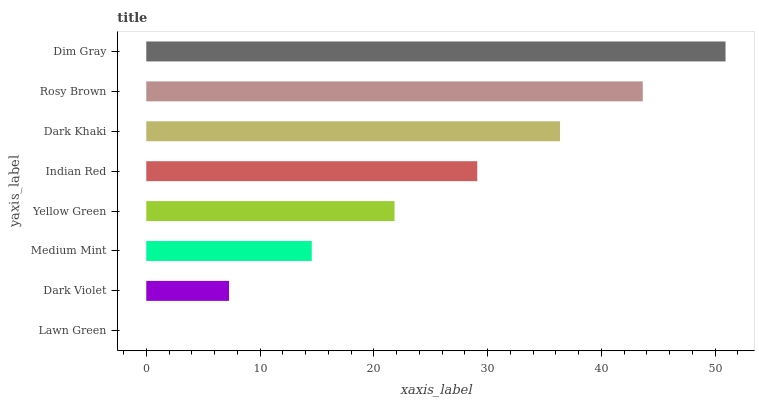Is Lawn Green the minimum?
Answer yes or no. Yes. Is Dim Gray the maximum?
Answer yes or no. Yes. Is Dark Violet the minimum?
Answer yes or no. No. Is Dark Violet the maximum?
Answer yes or no. No. Is Dark Violet greater than Lawn Green?
Answer yes or no. Yes. Is Lawn Green less than Dark Violet?
Answer yes or no. Yes. Is Lawn Green greater than Dark Violet?
Answer yes or no. No. Is Dark Violet less than Lawn Green?
Answer yes or no. No. Is Indian Red the high median?
Answer yes or no. Yes. Is Yellow Green the low median?
Answer yes or no. Yes. Is Dark Violet the high median?
Answer yes or no. No. Is Dim Gray the low median?
Answer yes or no. No. 